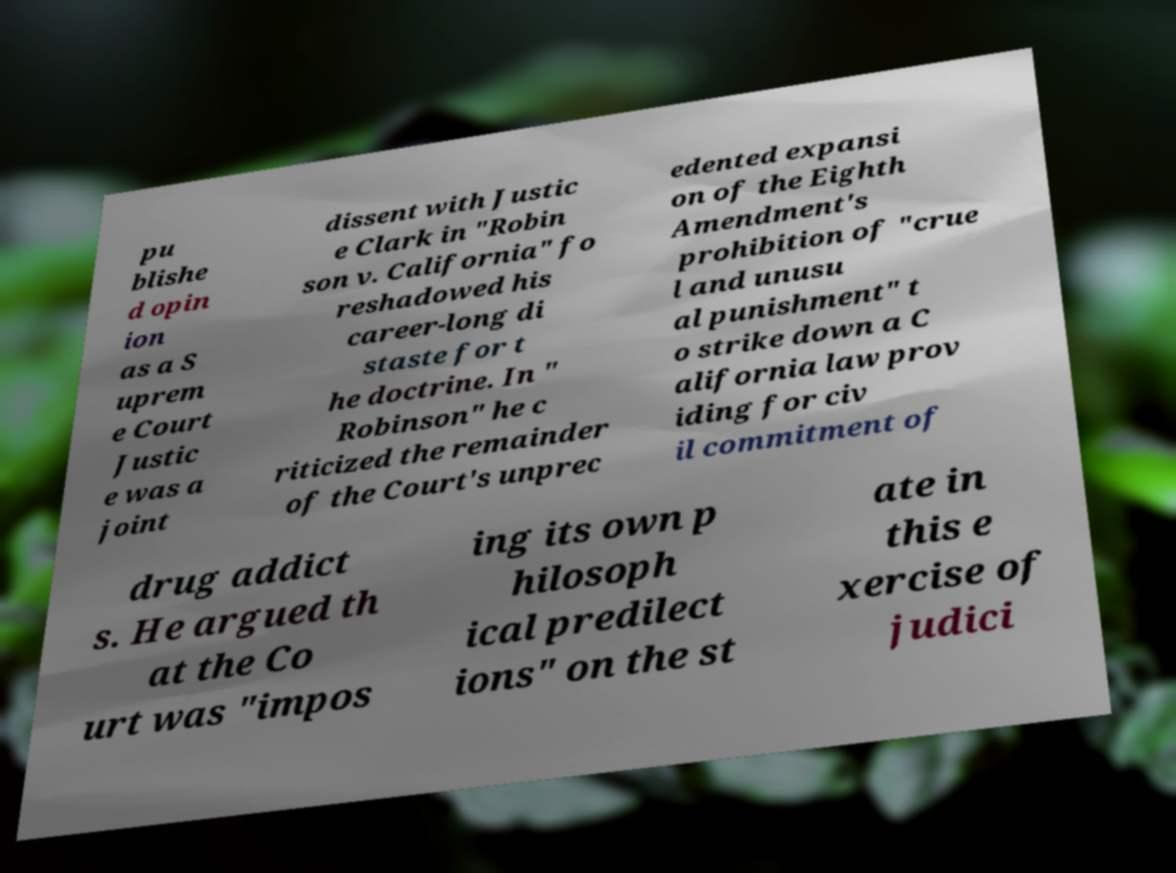Could you assist in decoding the text presented in this image and type it out clearly? pu blishe d opin ion as a S uprem e Court Justic e was a joint dissent with Justic e Clark in "Robin son v. California" fo reshadowed his career-long di staste for t he doctrine. In " Robinson" he c riticized the remainder of the Court's unprec edented expansi on of the Eighth Amendment's prohibition of "crue l and unusu al punishment" t o strike down a C alifornia law prov iding for civ il commitment of drug addict s. He argued th at the Co urt was "impos ing its own p hilosoph ical predilect ions" on the st ate in this e xercise of judici 